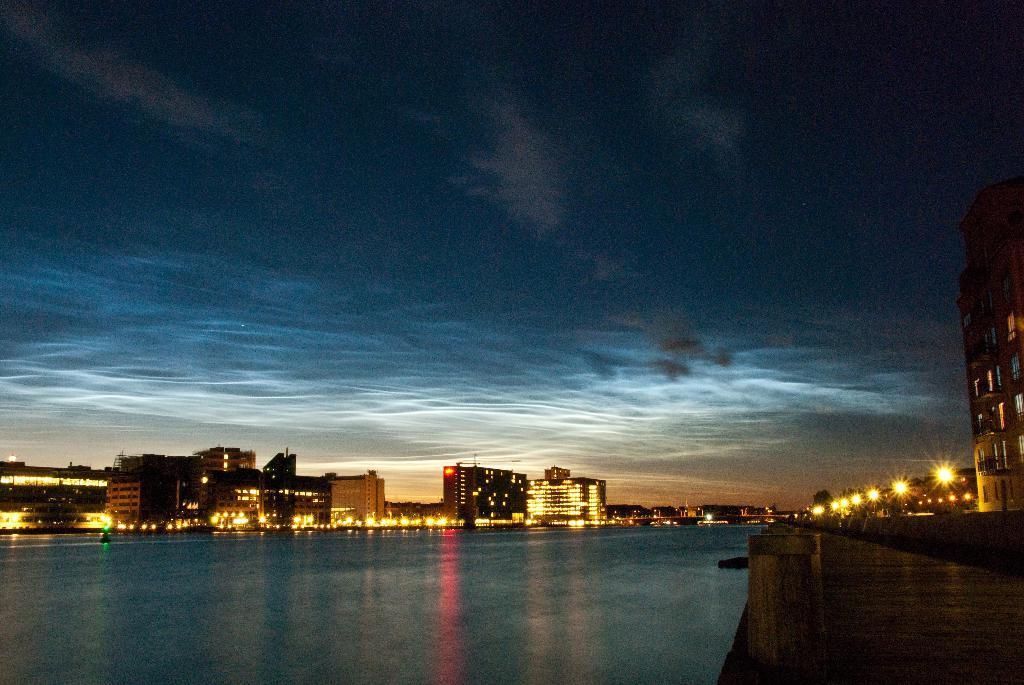Please provide a concise description of this image. In this picture I can see buildings and I can see water and few lights and I can see a cloudy sky. 